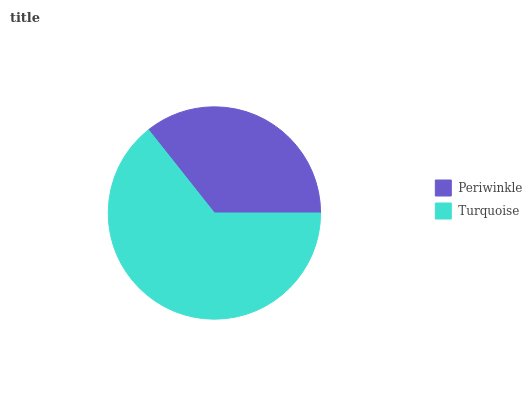Is Periwinkle the minimum?
Answer yes or no. Yes. Is Turquoise the maximum?
Answer yes or no. Yes. Is Turquoise the minimum?
Answer yes or no. No. Is Turquoise greater than Periwinkle?
Answer yes or no. Yes. Is Periwinkle less than Turquoise?
Answer yes or no. Yes. Is Periwinkle greater than Turquoise?
Answer yes or no. No. Is Turquoise less than Periwinkle?
Answer yes or no. No. Is Turquoise the high median?
Answer yes or no. Yes. Is Periwinkle the low median?
Answer yes or no. Yes. Is Periwinkle the high median?
Answer yes or no. No. Is Turquoise the low median?
Answer yes or no. No. 